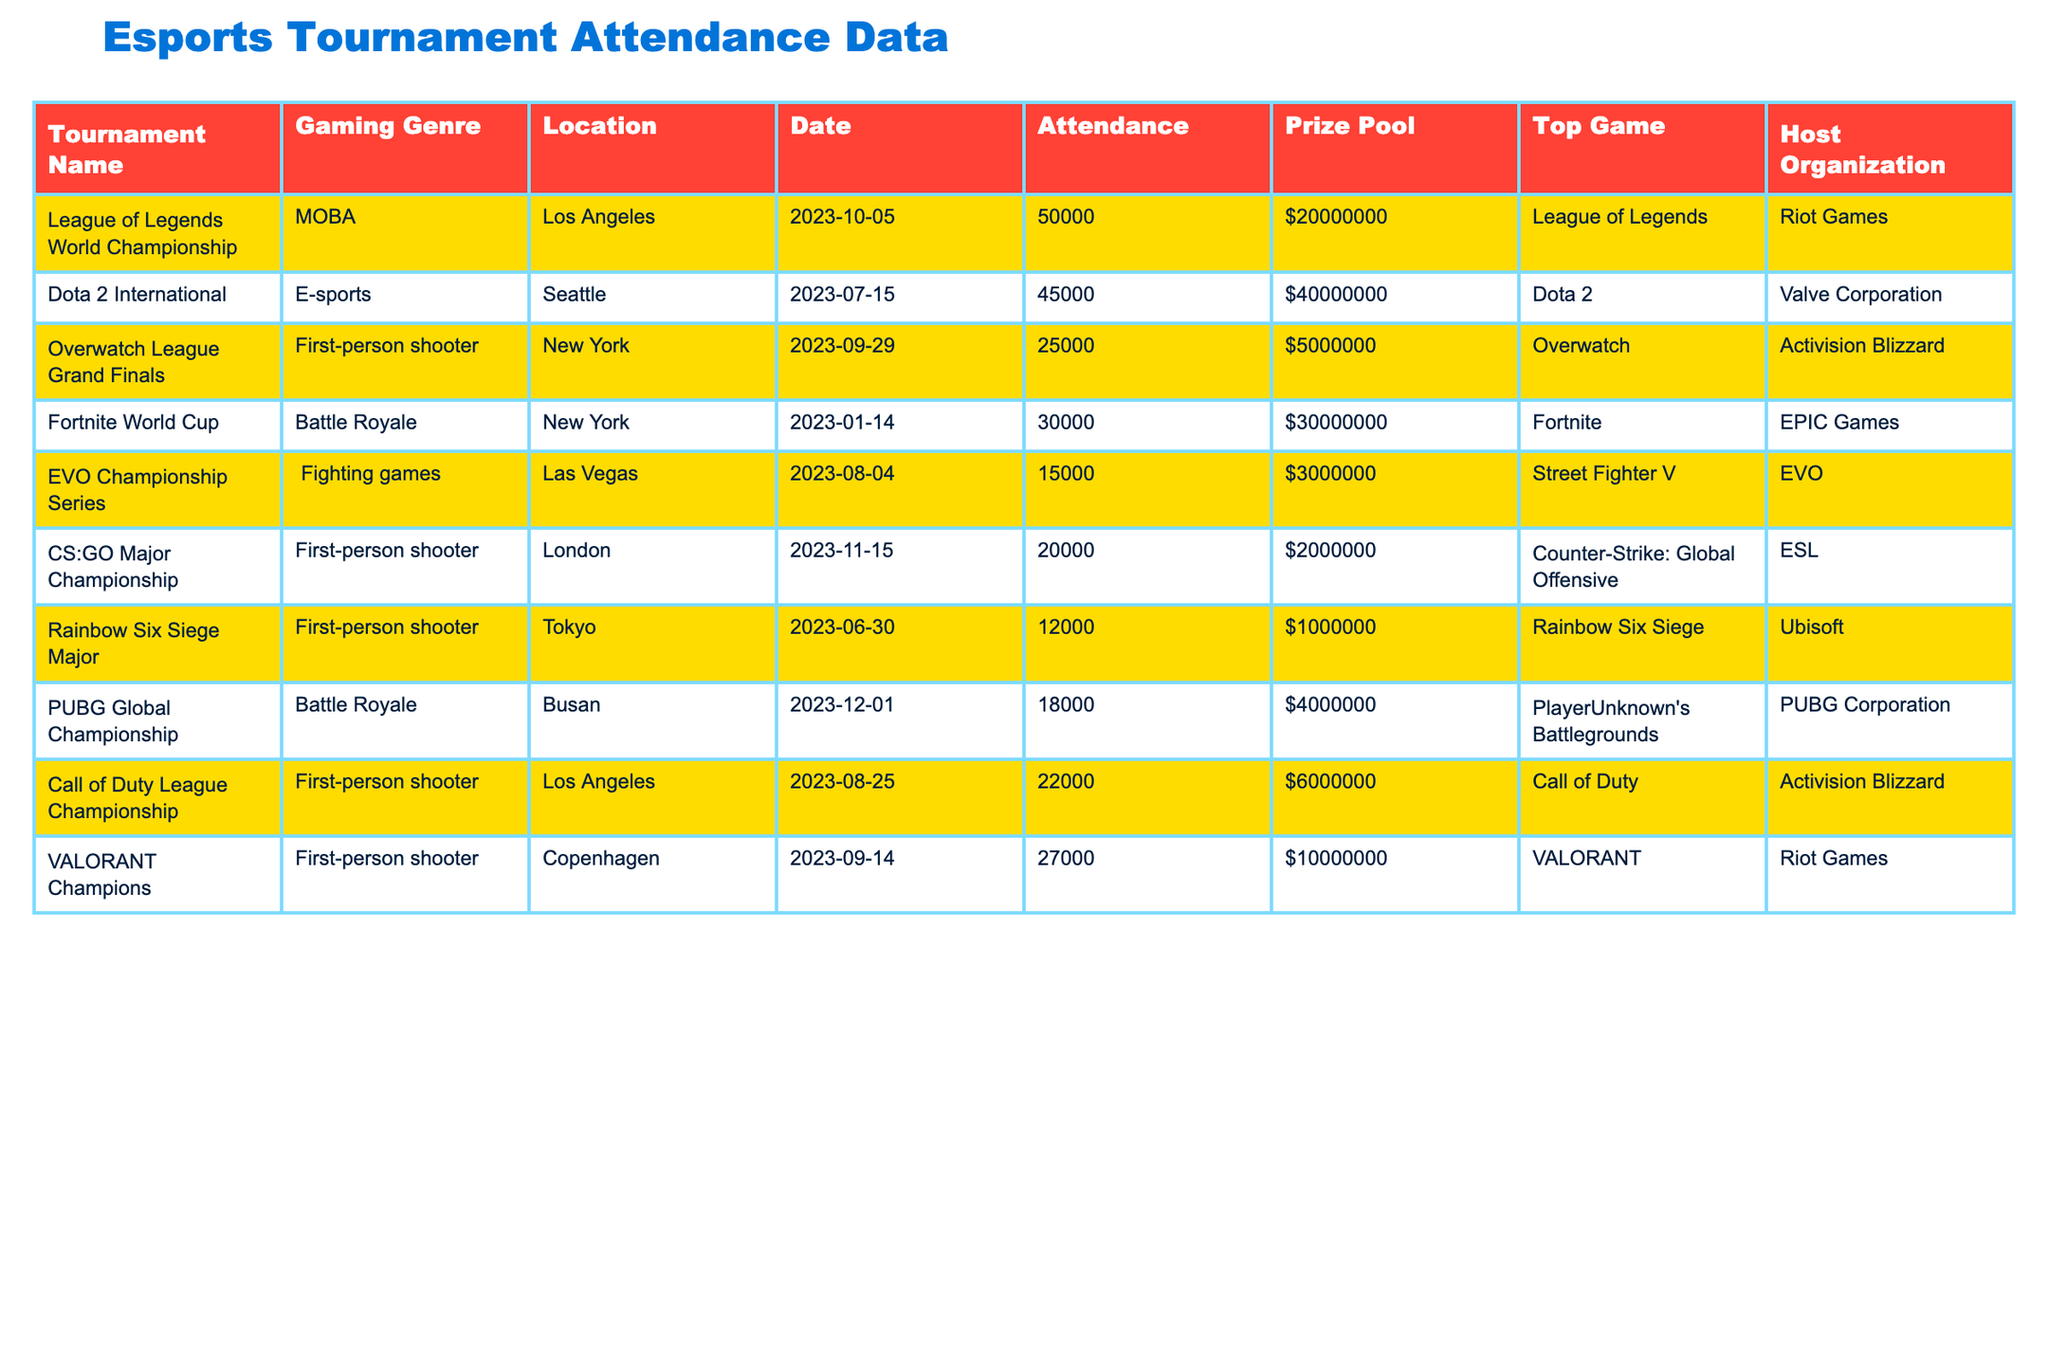What is the highest attendance recorded at an esports tournament in this table? The highest attendance listed is 50,000 at the League of Legends World Championship.
Answer: 50,000 Which gaming genre has the largest prize pool among the tournaments listed? The largest prize pool is $40,000,000 for the Dota 2 International, which is in the E-sports genre.
Answer: E-sports How many attendees were present at the Overwatch League Grand Finals? The table states that the attendance for the Overwatch League Grand Finals was 25,000.
Answer: 25,000 What is the average attendance across all tournaments? The total attendance is (50,000 + 45,000 + 25,000 + 30,000 + 15,000 + 20,000 + 12,000 + 18,000 + 22,000 + 27,000) =  249,000. Divided by 10 tournaments, the average attendance is 249,000 / 10 = 24,900.
Answer: 24,900 Is the prize pool for the League of Legends World Championship greater than the total prize pool of the EVO Championship Series and the Rainbow Six Siege Major combined? The prize pool for the League of Legends World Championship is $20,000,000, while the sum of the EVO Championship Series ($3,000,000) and the Rainbow Six Siege Major ($1,000,000) is $4,000,000. Since $20,000,000 > $4,000,000, the answer is yes.
Answer: Yes What is the difference in attendance between the highest and lowest attended tournaments? The highest attended tournament is the League of Legends World Championship with 50,000 attendees, and the lowest is the Rainbow Six Siege Major with 12,000 attendees. The difference is 50,000 - 12,000 = 38,000.
Answer: 38,000 How many tournaments were hosted in New York, and what were their names? The table lists two tournaments held in New York: the Overwatch League Grand Finals and the Fortnite World Cup.
Answer: 2 tournaments: Overwatch League Grand Finals, Fortnite World Cup Which organization hosted the tournament with the lowest attendance, and what was that attendance? The lowest attended tournament is the Rainbow Six Siege Major with 12,000 attendees hosted by Ubisoft.
Answer: Ubisoft; 12,000 attendees What percentage of the total prize pool is allocated to the Fortnite World Cup? The total prize pool is $20,000,000 (League of Legends) + $40,000,000 (Dota 2) + $5,000,000 (Overwatch) + $30,000,000 (Fortnite) + $3,000,000 (EVO) + $2,000,000 (CS:GO) + $1,000,000 (Rainbow Six) + $4,000,000 (PUBG) + $6,000,000 (Call of Duty) + $10,000,000 (VALORANT) = $121,000,000. The Fortnite World Cup's prize pool is $30,000,000. So the percentage is ($30,000,000 / $121,000,000) * 100 ≈ 24.79%.
Answer: Approximately 24.79% Which gaming genre has the most tournaments listed in this table? After reviewing the table, the First-person shooter genre has four tournaments (Overwatch League, CS:GO Major, Rainbow Six Siege Major, Call of Duty League, and VALORANT Champions).
Answer: First-person shooter 